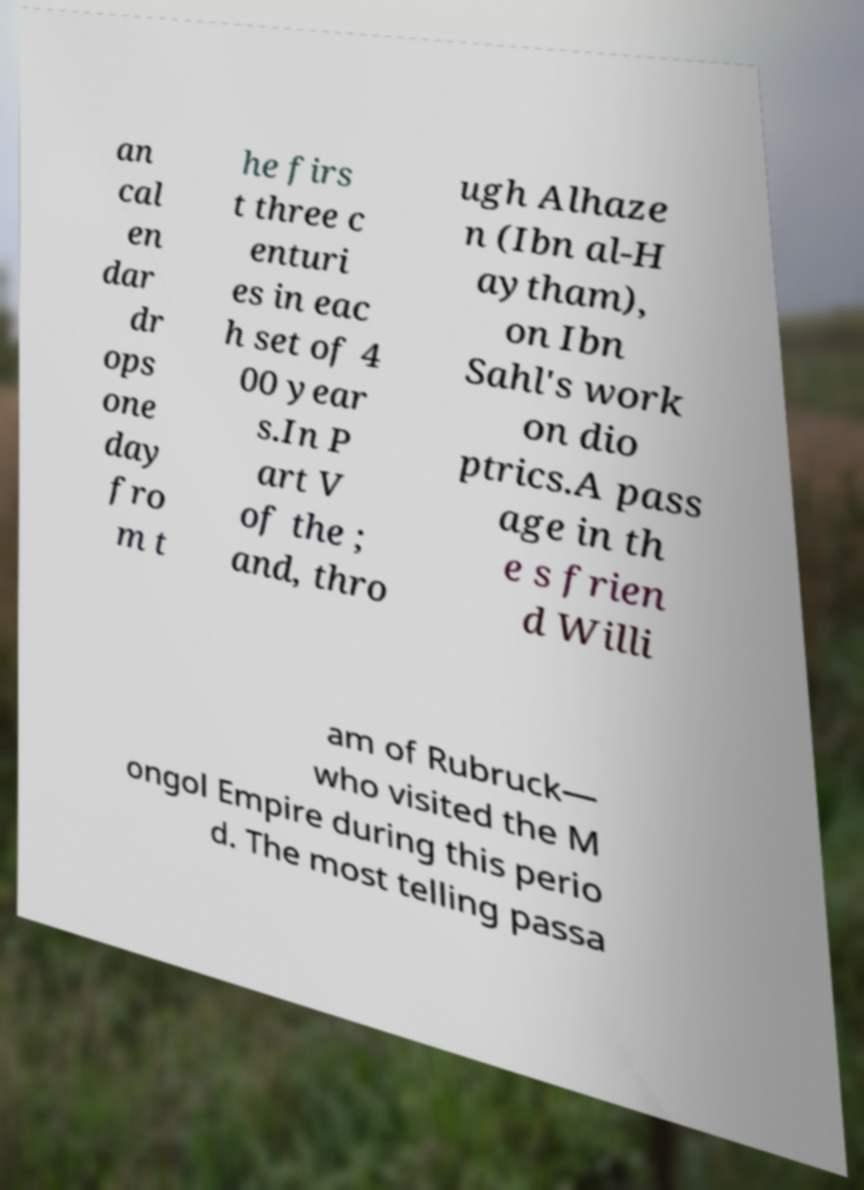For documentation purposes, I need the text within this image transcribed. Could you provide that? an cal en dar dr ops one day fro m t he firs t three c enturi es in eac h set of 4 00 year s.In P art V of the ; and, thro ugh Alhaze n (Ibn al-H aytham), on Ibn Sahl's work on dio ptrics.A pass age in th e s frien d Willi am of Rubruck— who visited the M ongol Empire during this perio d. The most telling passa 